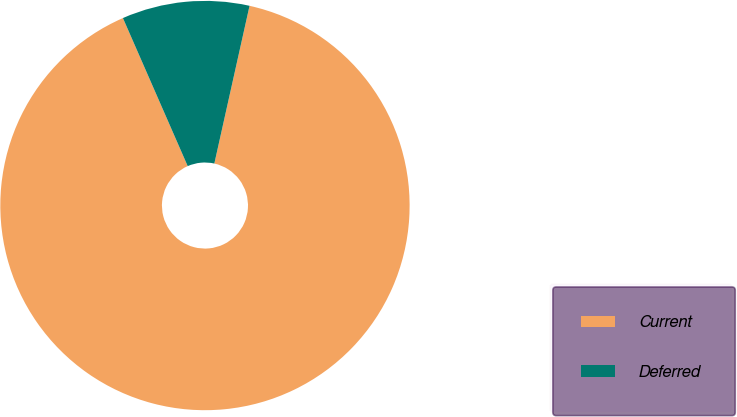<chart> <loc_0><loc_0><loc_500><loc_500><pie_chart><fcel>Current<fcel>Deferred<nl><fcel>89.94%<fcel>10.06%<nl></chart> 